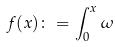<formula> <loc_0><loc_0><loc_500><loc_500>f ( x ) \colon = \int _ { 0 } ^ { x } \omega</formula> 